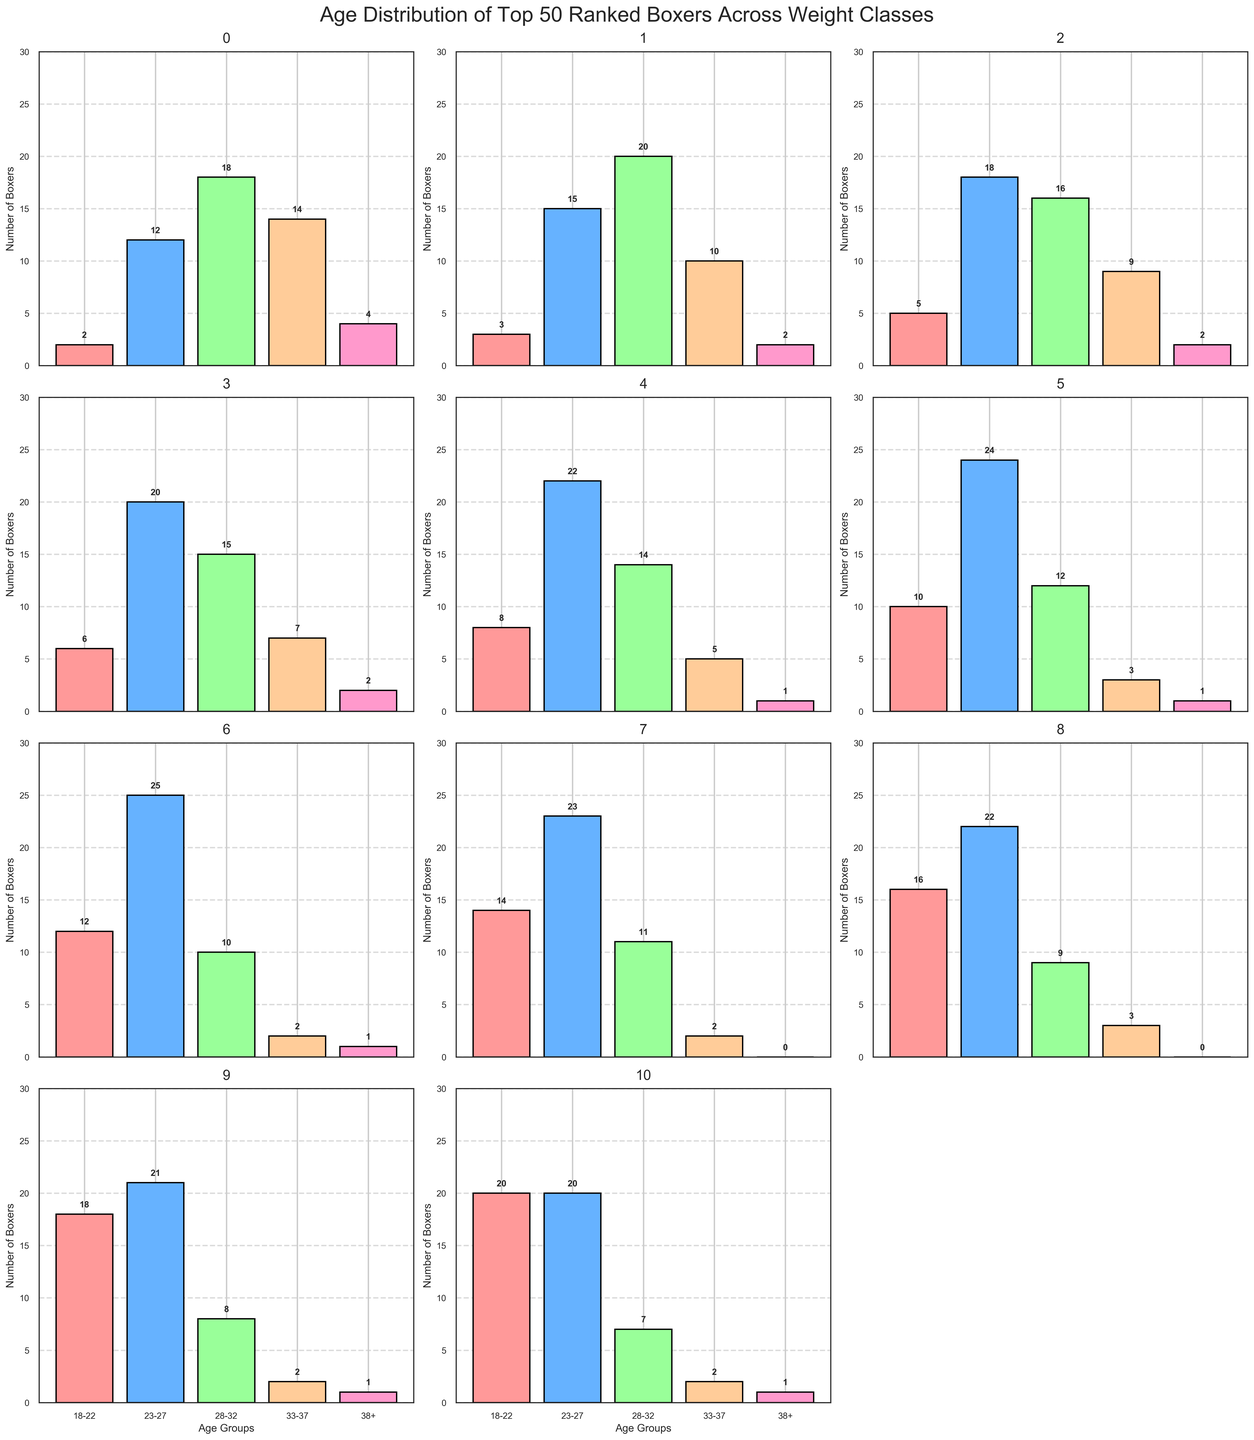What is the title of the figure? The title is displayed at the top of the figure, which summarizes the objective of the plots. The title reads "Age Distribution of Top 50 Ranked Boxers Across Weight Classes."
Answer: Age Distribution of Top 50 Ranked Boxers Across Weight Classes How many boxers are there in the '18-22' age group for the Heavyweight class? Locate the Heavyweight subplot and the corresponding bar for the '18-22' age group, which is labeled just above the bar. The number is 2.
Answer: 2 Which weight class has the highest number of boxers in the '23-27' age group? Compare the heights of the bars in the '23-27' category across all subplots. The Welterweight class has the tallest bar labeled with 25 boxers.
Answer: Welterweight What is the total number of boxers aged 33-37 across all weight classes? Sum the '33-37' values from each subplot: 14+10+9+7+5+3+2+2+3+2+2 = 59.
Answer: 59 Which two weight classes have an equal number of boxers in the '38+' age group? Check the heights of the '38+' bars across all subplots to find matching values. Cruiserweight and Light Heavyweight both have 2 boxers in this category.
Answer: Cruiserweight, Light Heavyweight What is the average number of boxers in the '28-32' age group for Super Welterweight and Featherweight classes? Compute the average by adding the numbers for Super Welterweight (12) and Featherweight (7), and then divide by 2: (12+7)/2 = 19/2 = 9.5.
Answer: 9.5 Which weight class has the most balanced distribution of boxers across all age groups? Review the bar heights in each subplot to determine which has relatively even heights. The Super Middleweight class has a more balanced distribution with bars labeled as 6, 20, 15, 7, and 2.
Answer: Super Middleweight Which age group has the highest frequency across all weight classes? Sum the values for each age group across all subplots: 
18-22: 2+3+5+6+8+10+12+14+16+18+20 = 114,
23-27: 12+15+18+20+22+24+25+23+22+21+20 = 222,
28-32: 18+20+16+15+14+12+10+11+9+8+7 = 140,
33-37: 14+10+9+7+5+3+2+2+3+2+2 = 59,
38+: 4+2+2+2+1+1+1+0+0+1+1 = 15.
The '23-27' age group has the highest sum with 222.
Answer: 23-27 How many weight classes have more than 30 boxers in the '18-22' and '23-27' age groups combined? Add the '18-22' and '23-27' values for each subplot to find the total, then count the subplots where this sum exceeds 30:
Heavyweight: 2+12=14,
Cruiserweight: 3+15=18,
Light Heavyweight: 5+18=23,
Super Middleweight: 6+20=26,
Middleweight: 8+22=30,
Super Welterweight: 10+24=34,
Welterweight: 12+25=37,
Super Lightweight: 14+23=37,
Lightweight: 16+22=38,
Super Featherweight: 18+21=39,
Featherweight: 20+20=40.
Only four weight classes have totals exceeding 30: Super Welterweight, Welterweight, Super Lightweight, Lightweight, and Featherweight.
Answer: 5 